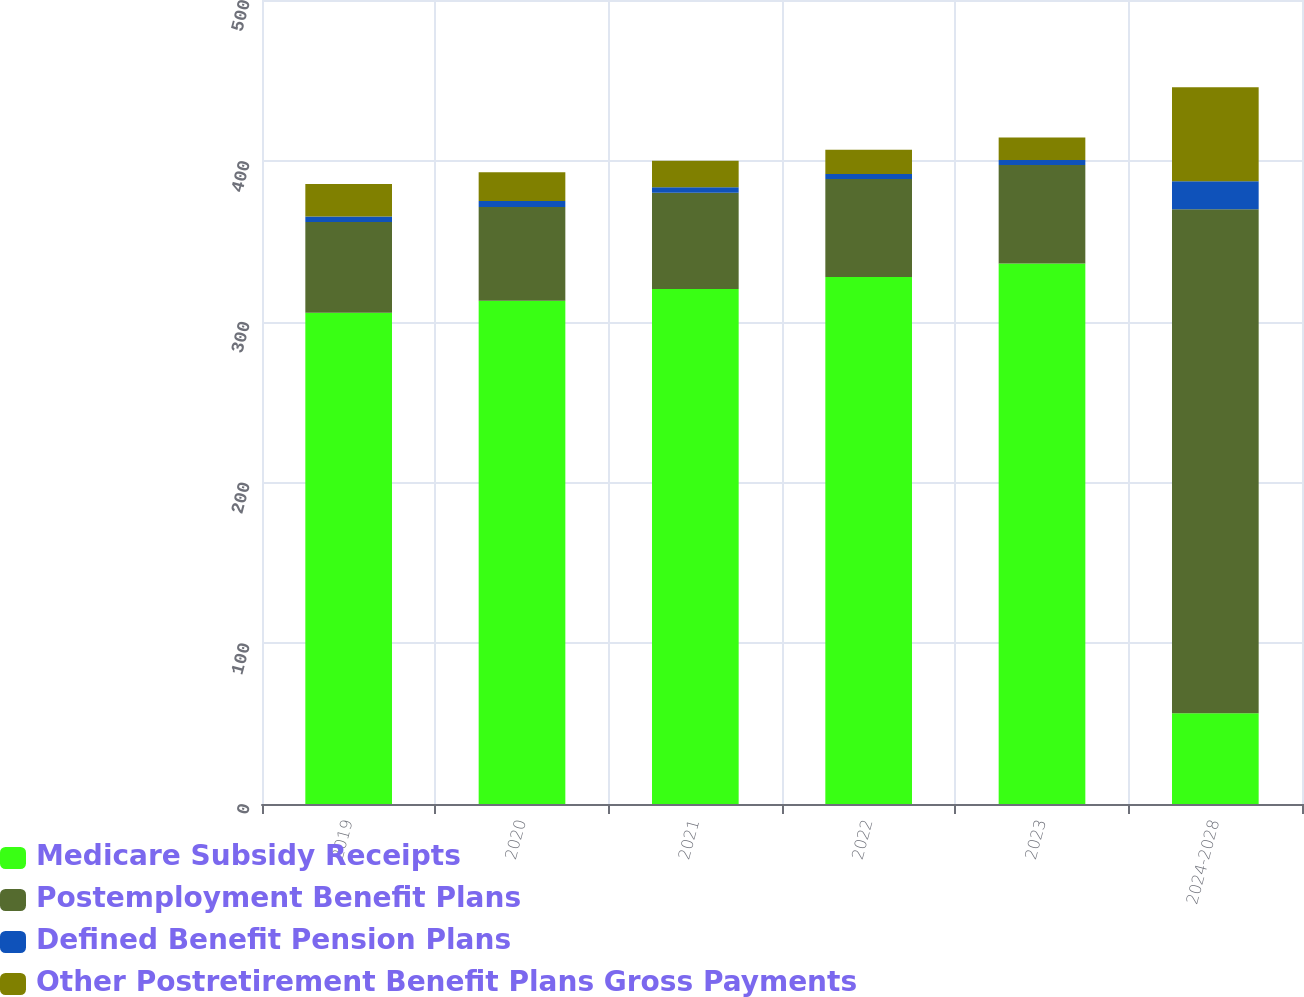Convert chart. <chart><loc_0><loc_0><loc_500><loc_500><stacked_bar_chart><ecel><fcel>2019<fcel>2020<fcel>2021<fcel>2022<fcel>2023<fcel>2024-2028<nl><fcel>Medicare Subsidy Receipts<fcel>305.5<fcel>313<fcel>320.3<fcel>327.8<fcel>336.1<fcel>56.5<nl><fcel>Postemployment Benefit Plans<fcel>56.5<fcel>58.3<fcel>59.8<fcel>60.9<fcel>61.3<fcel>313.3<nl><fcel>Defined Benefit Pension Plans<fcel>3.4<fcel>3.7<fcel>3.5<fcel>3.1<fcel>3.1<fcel>17.5<nl><fcel>Other Postretirement Benefit Plans Gross Payments<fcel>20.2<fcel>17.9<fcel>16.4<fcel>15.1<fcel>14<fcel>58.4<nl></chart> 